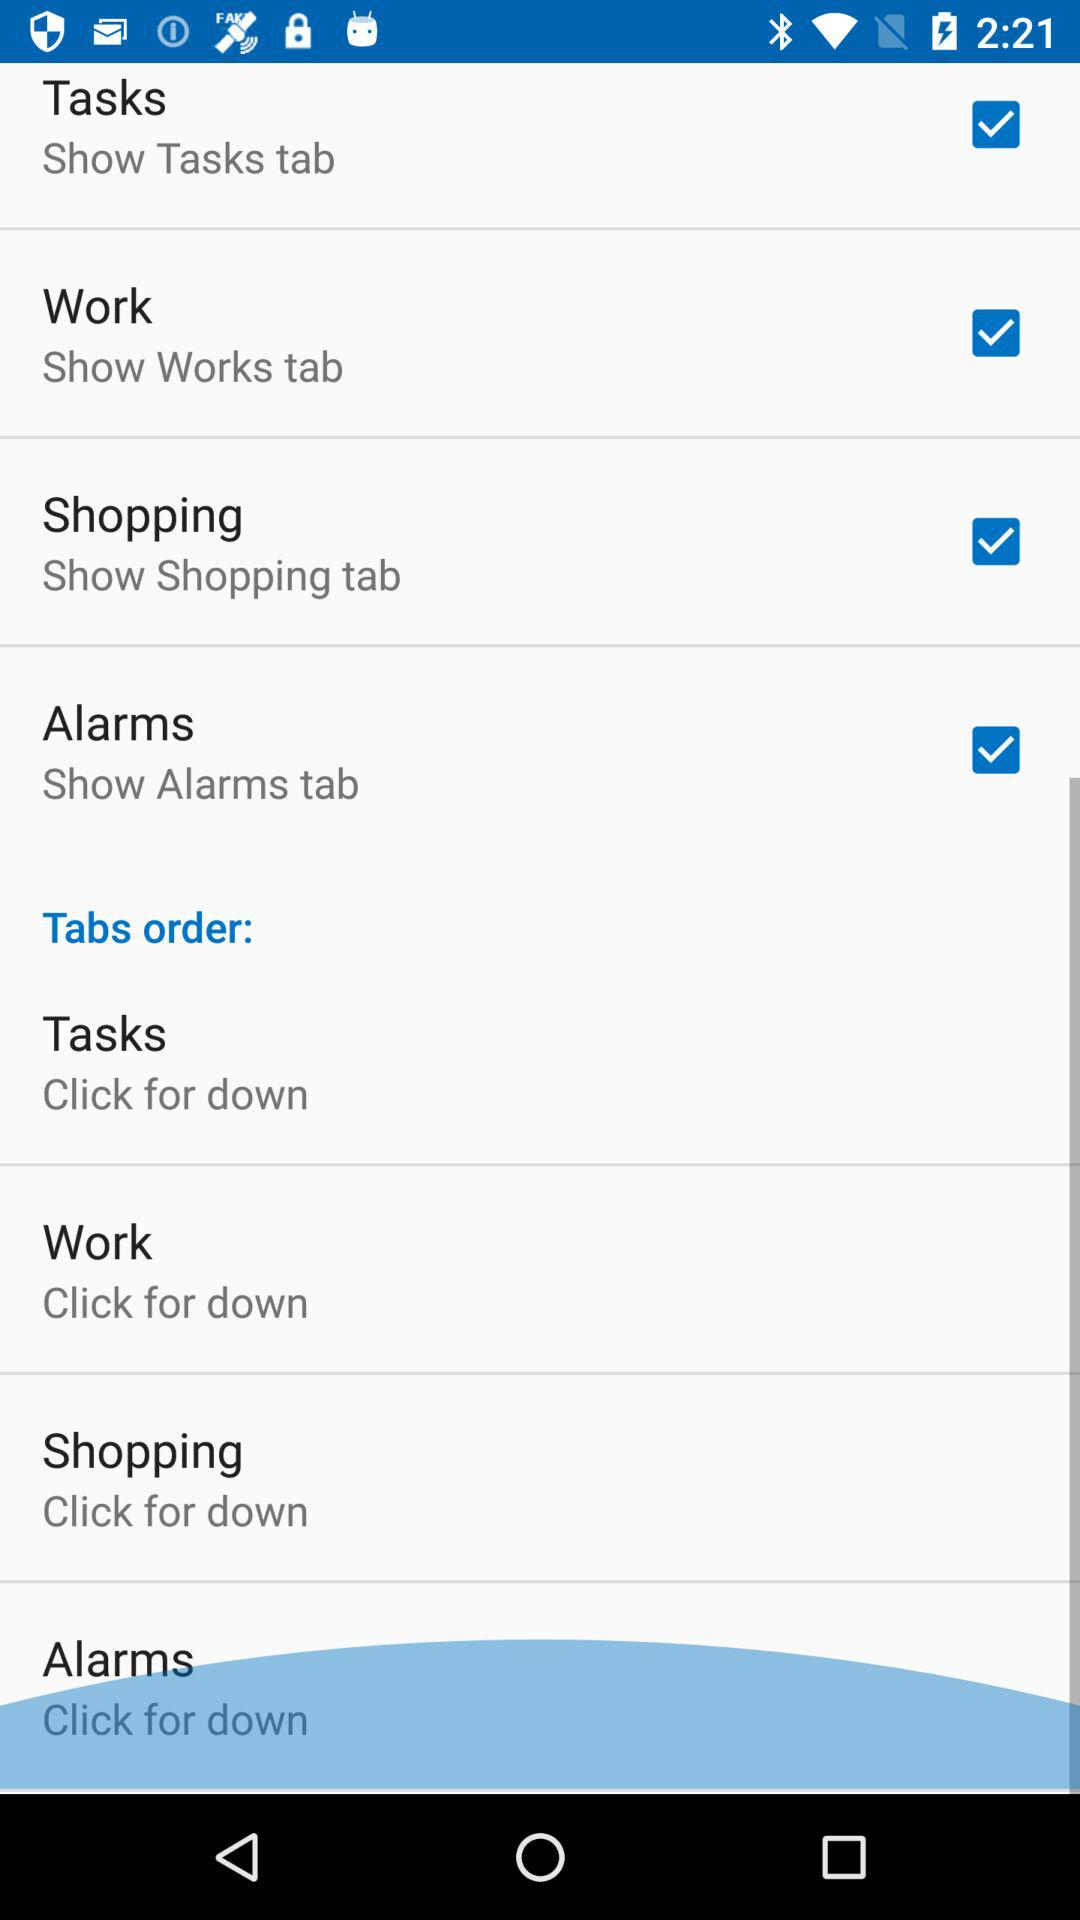How many tabs are there in total?
Answer the question using a single word or phrase. 4 